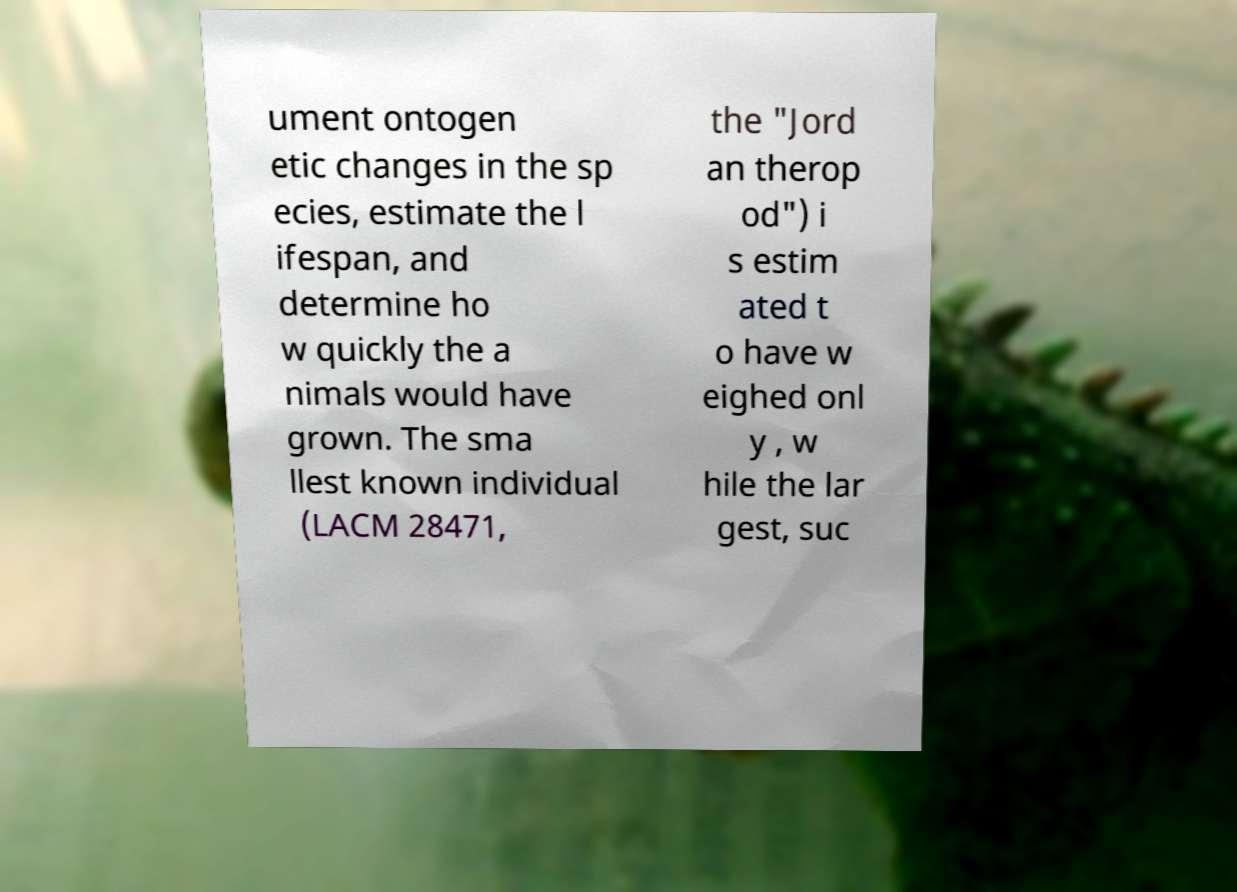Please identify and transcribe the text found in this image. ument ontogen etic changes in the sp ecies, estimate the l ifespan, and determine ho w quickly the a nimals would have grown. The sma llest known individual (LACM 28471, the "Jord an therop od") i s estim ated t o have w eighed onl y , w hile the lar gest, suc 